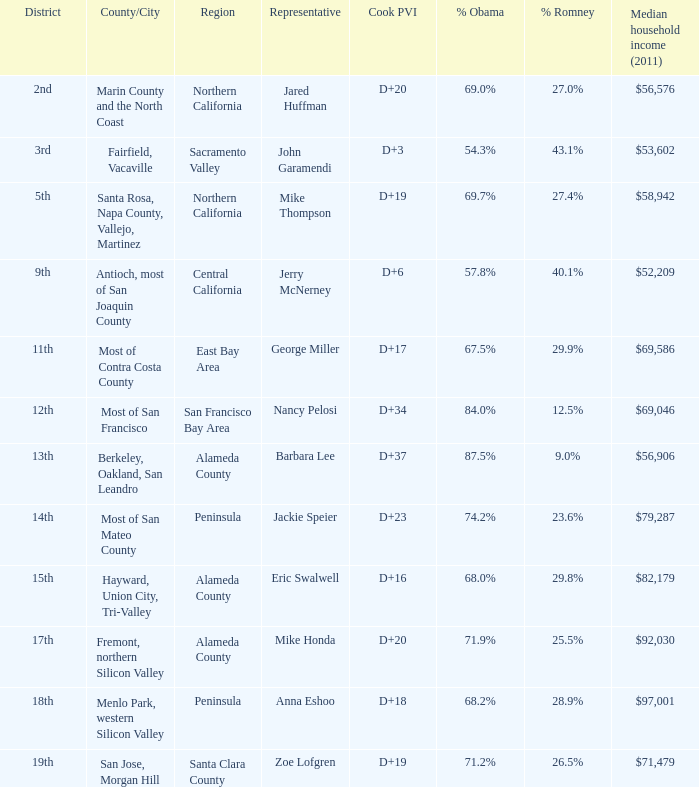How many locations have a median household income in 2011 of $71,479? 1.0. 